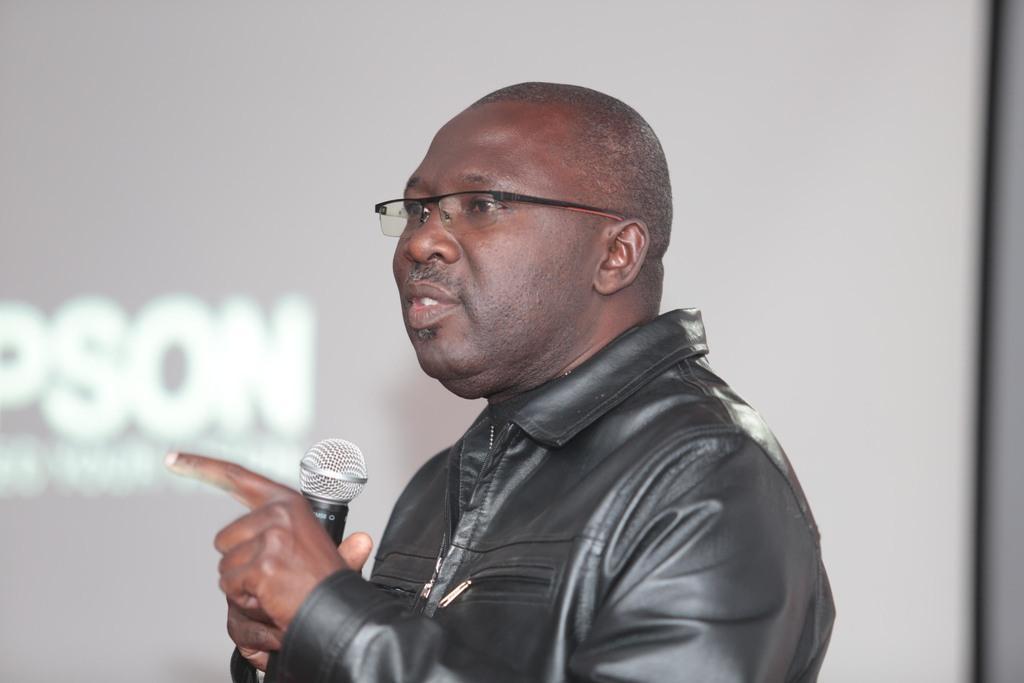How would you summarize this image in a sentence or two? In the picture I can see a man wearing a black color jacket and he is speaking on a microphone. In the background, I can see the screen and there is a text on the screen. 